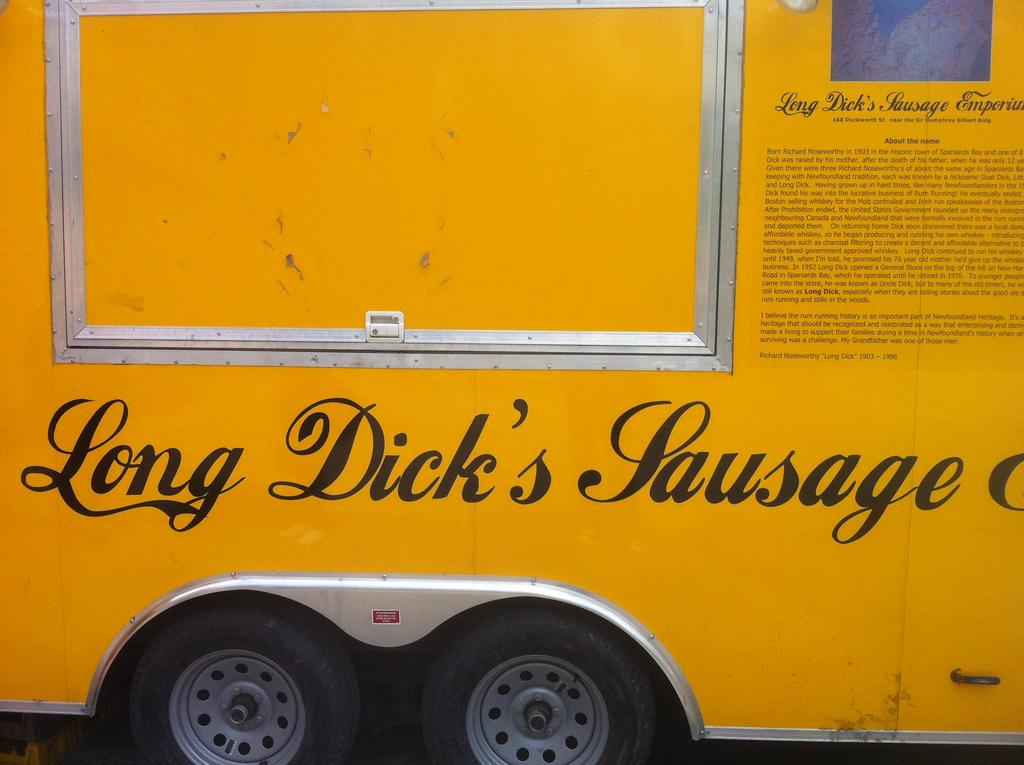What is the main subject of the image? The main subject of the image is a vehicle. What feature does the vehicle have that allows it to move? The vehicle has wheels. Is there any text present on the vehicle? Yes, there is text on the vehicle. How much soup can be seen in the image? There is no soup present in the image. What type of things are being transported by the vehicle in the image? The image does not provide information about what the vehicle is transporting, so we cannot determine the type of things being transported. 